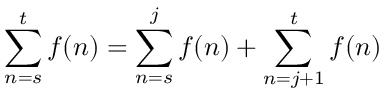Convert formula to latex. <formula><loc_0><loc_0><loc_500><loc_500>\sum _ { n = s } ^ { t } f ( n ) = \sum _ { n = s } ^ { j } f ( n ) + \sum _ { n = j + 1 } ^ { t } f ( n )</formula> 